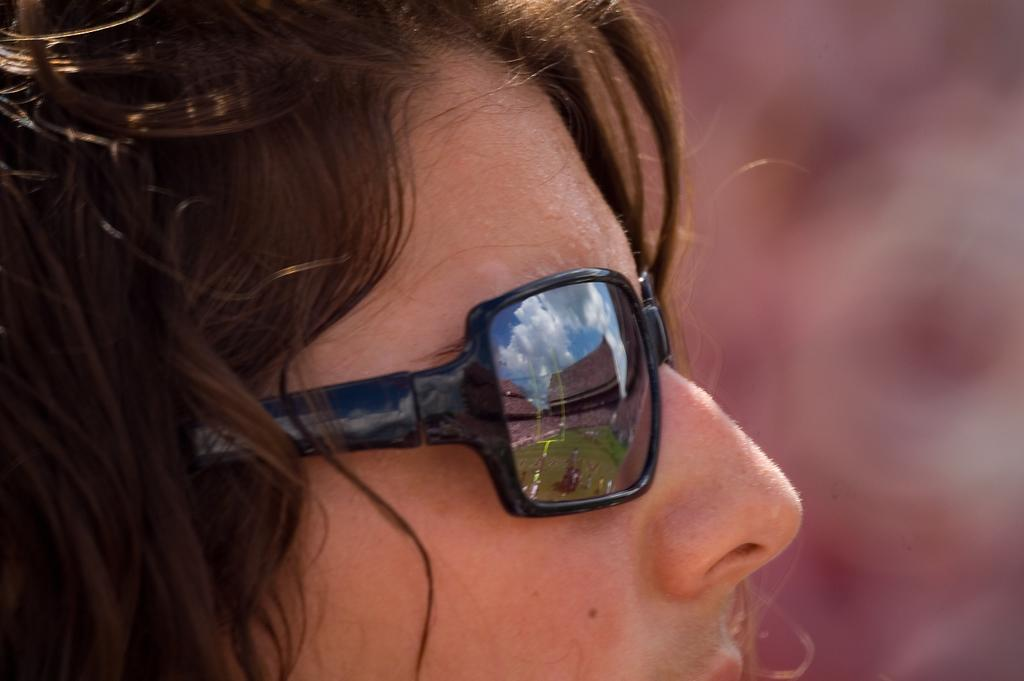Who is present in the image? There are women in the image. What are the women wearing in the image? The women are wearing spectacles. What type of spy equipment can be seen in the image? There is no spy equipment present in the image; it features women wearing spectacles. Is there a jail visible in the image? There is no jail present in the image. 